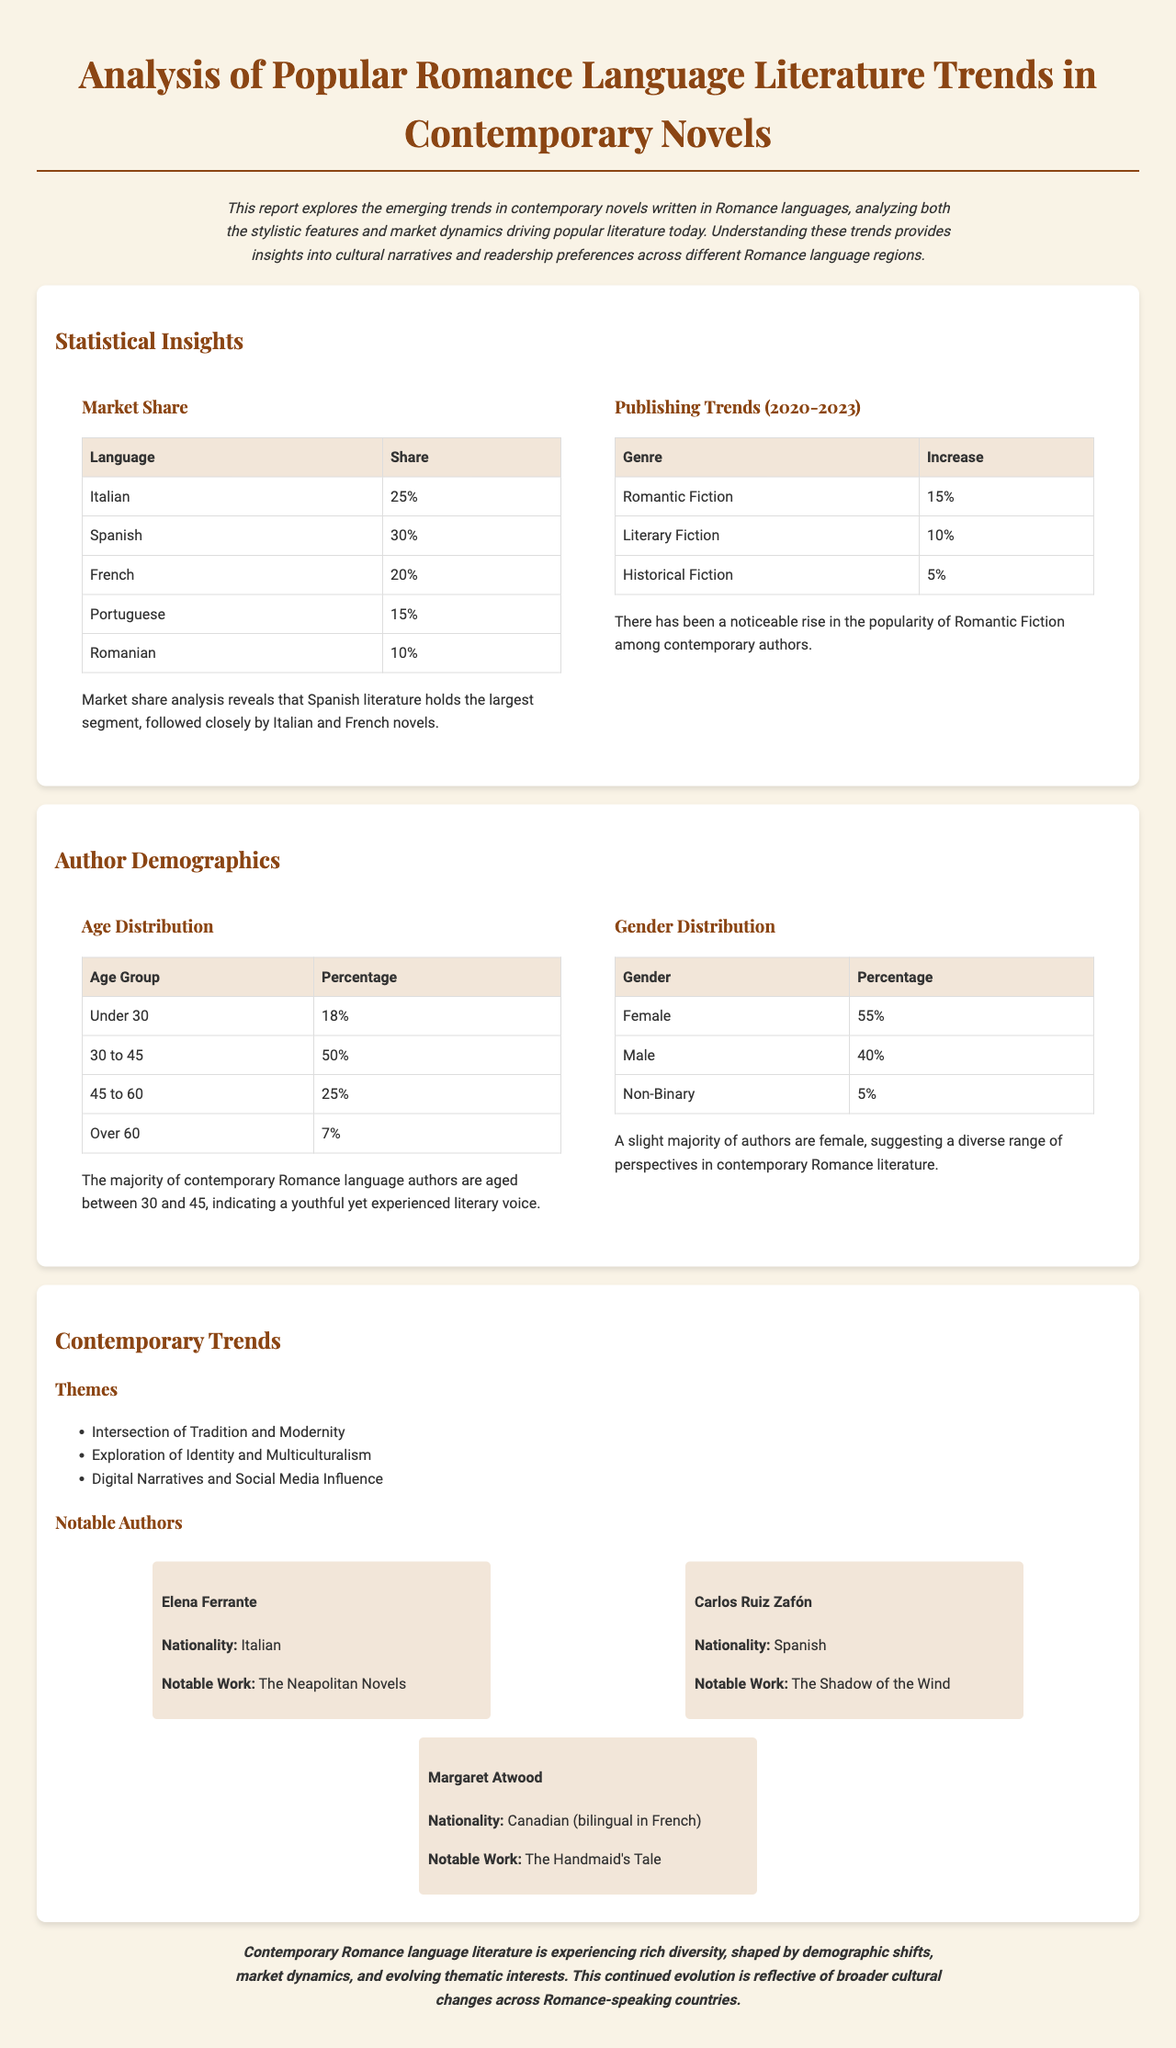what is the largest market share? The market share analysis reveals that Spanish literature holds the largest segment at 30%.
Answer: 30% what percentage of authors are female? The document indicates that 55% of authors are female, suggesting a diverse range of perspectives.
Answer: 55% which genre saw a 15% increase? The publishing trends show a noticeable rise in Romantic Fiction, which had a 15% increase.
Answer: Romantic Fiction what is the age group with the highest percentage of authors? According to the age distribution table, the age group 30 to 45 has the highest percentage of authors at 50%.
Answer: 30 to 45 who is a notable author from Spain? The document mentions Carlos Ruiz Zafón as a notable Spanish author.
Answer: Carlos Ruiz Zafón what themes are explored in contemporary Romance language literature? The document lists significant themes such as the intersection of Tradition and Modernity, and Exploration of Identity and Multiculturalism.
Answer: Intersection of Tradition and Modernity how many percentages of authors are Non-Binary? The gender distribution table shows that 5% of authors identify as Non-Binary.
Answer: 5% which language has the smallest market share? Among the languages listed in the market share analysis, Romanian has the smallest segment at 10%.
Answer: Romanian 